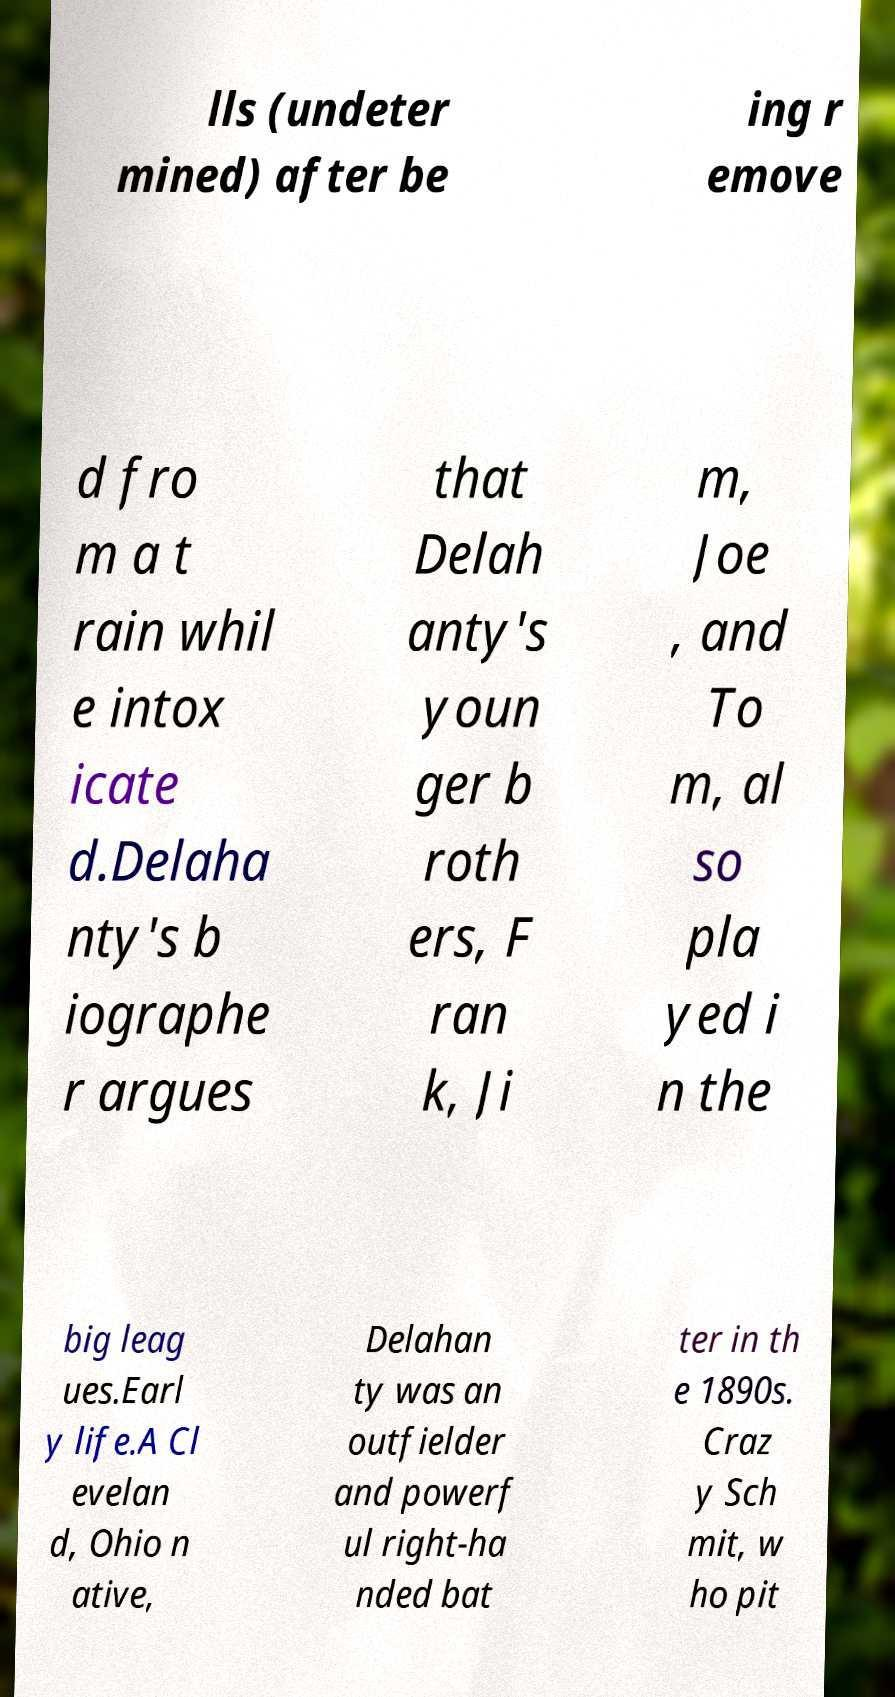Can you read and provide the text displayed in the image?This photo seems to have some interesting text. Can you extract and type it out for me? lls (undeter mined) after be ing r emove d fro m a t rain whil e intox icate d.Delaha nty's b iographe r argues that Delah anty's youn ger b roth ers, F ran k, Ji m, Joe , and To m, al so pla yed i n the big leag ues.Earl y life.A Cl evelan d, Ohio n ative, Delahan ty was an outfielder and powerf ul right-ha nded bat ter in th e 1890s. Craz y Sch mit, w ho pit 